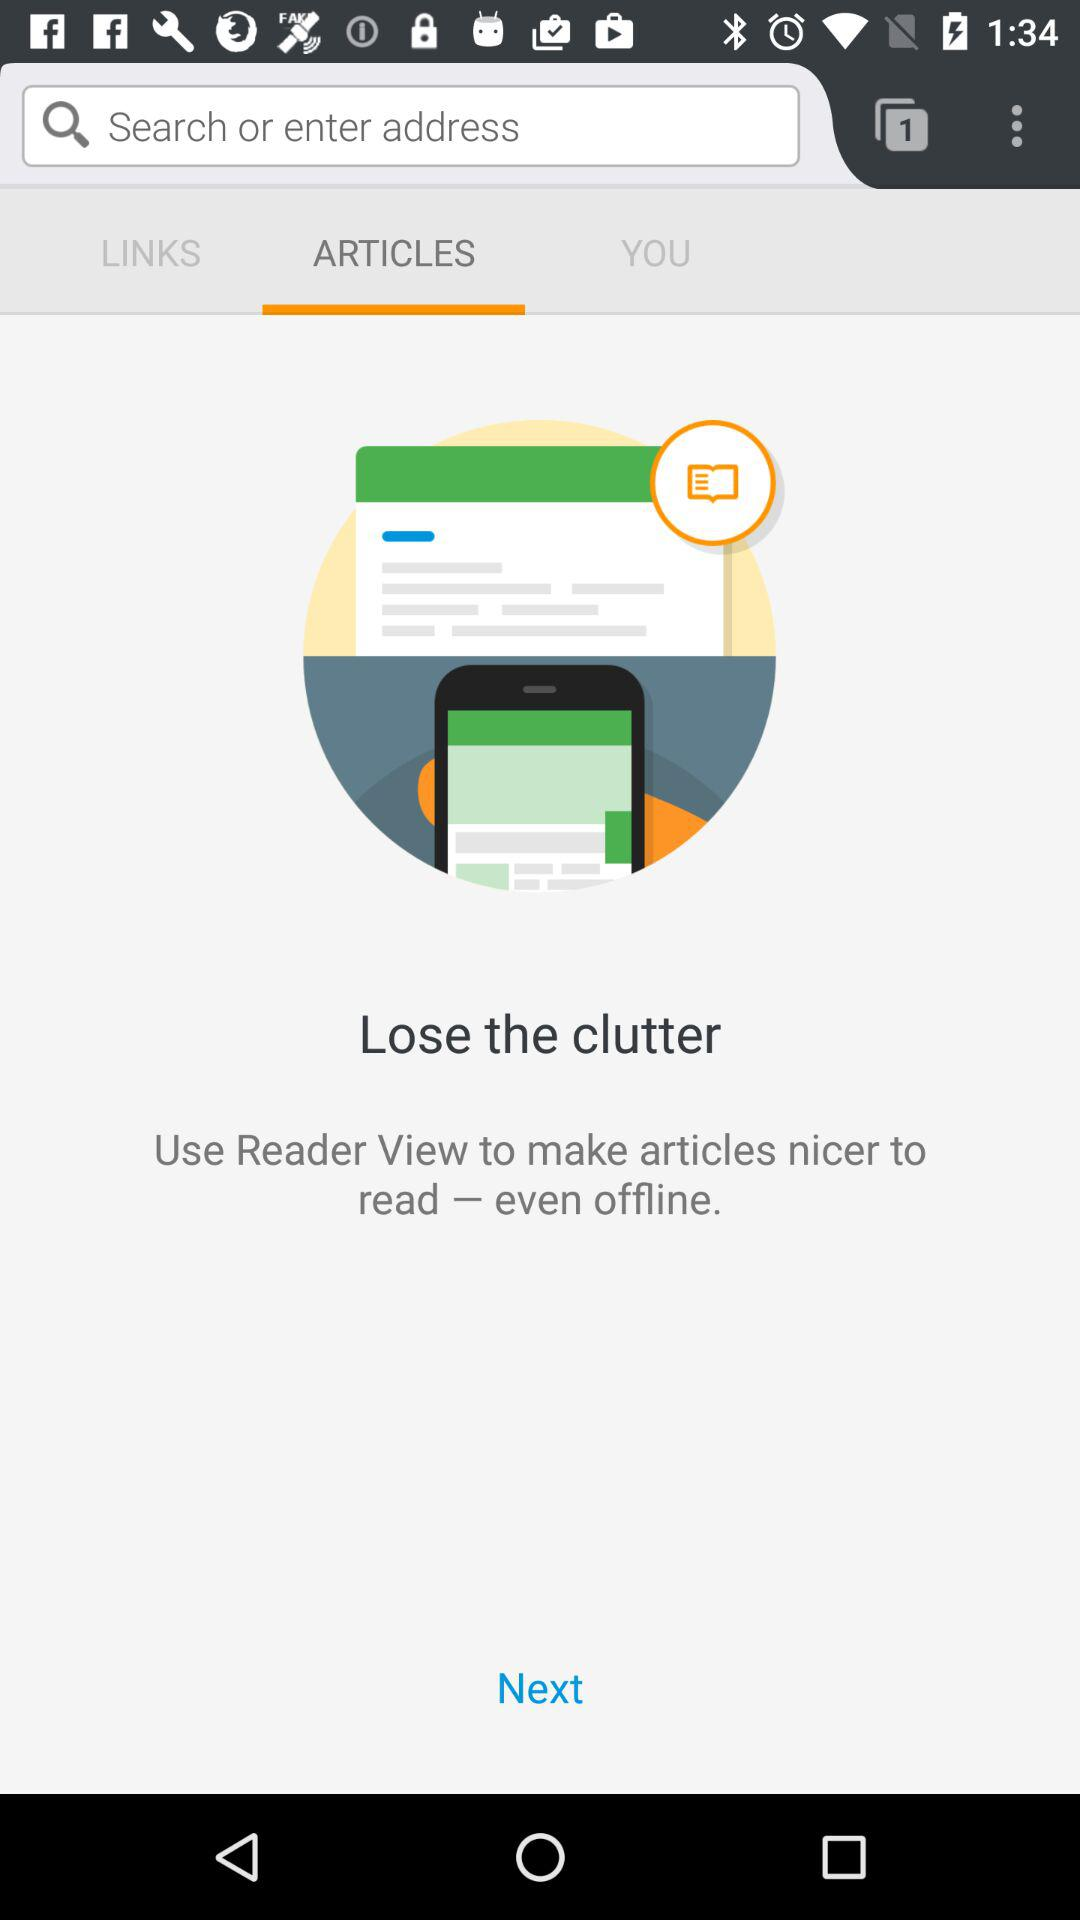How many unread notifications are there?
When the provided information is insufficient, respond with <no answer>. <no answer> 